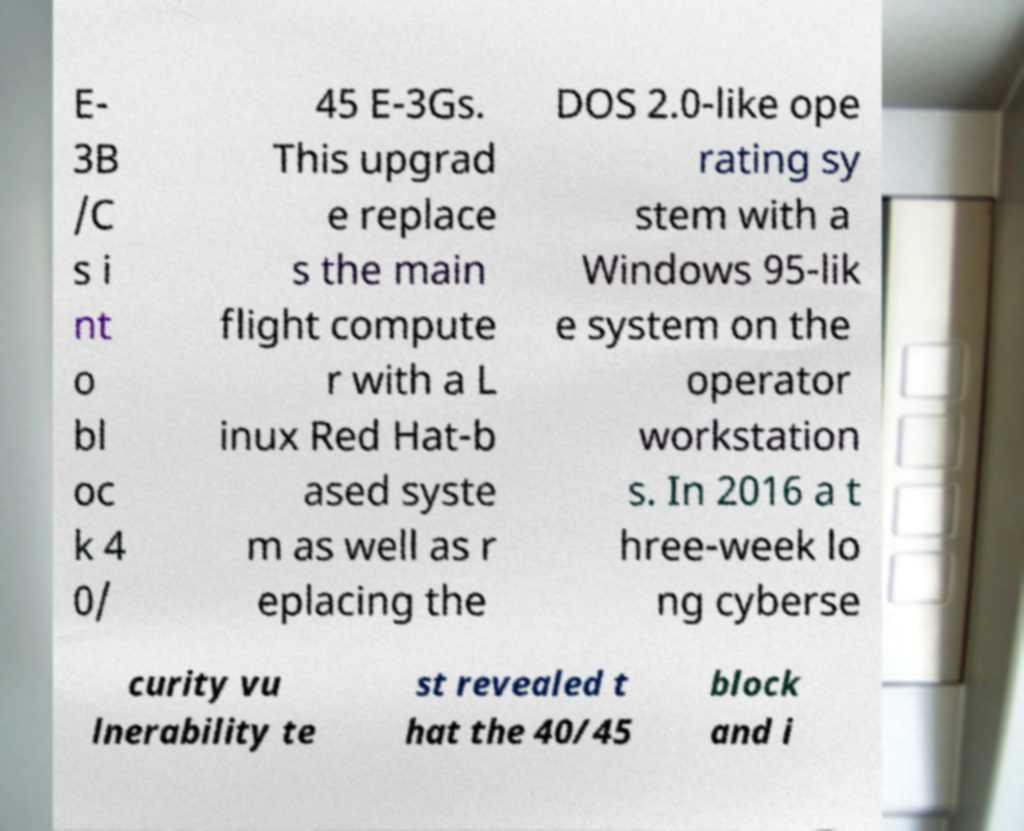Please identify and transcribe the text found in this image. E- 3B /C s i nt o bl oc k 4 0/ 45 E-3Gs. This upgrad e replace s the main flight compute r with a L inux Red Hat-b ased syste m as well as r eplacing the DOS 2.0-like ope rating sy stem with a Windows 95-lik e system on the operator workstation s. In 2016 a t hree-week lo ng cyberse curity vu lnerability te st revealed t hat the 40/45 block and i 